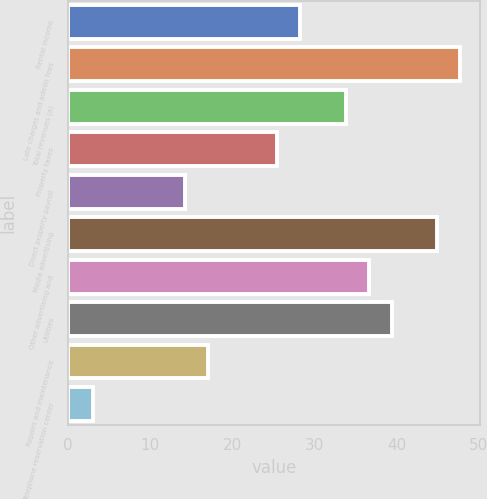<chart> <loc_0><loc_0><loc_500><loc_500><bar_chart><fcel>Rental income<fcel>Late charges and admin fees<fcel>Total revenues (a)<fcel>Property taxes<fcel>Direct property payroll<fcel>Media advertising<fcel>Other advertising and<fcel>Utilities<fcel>Repairs and maintenance<fcel>Telephone reservation center<nl><fcel>28.2<fcel>47.8<fcel>33.8<fcel>25.4<fcel>14.2<fcel>45<fcel>36.6<fcel>39.4<fcel>17<fcel>3<nl></chart> 